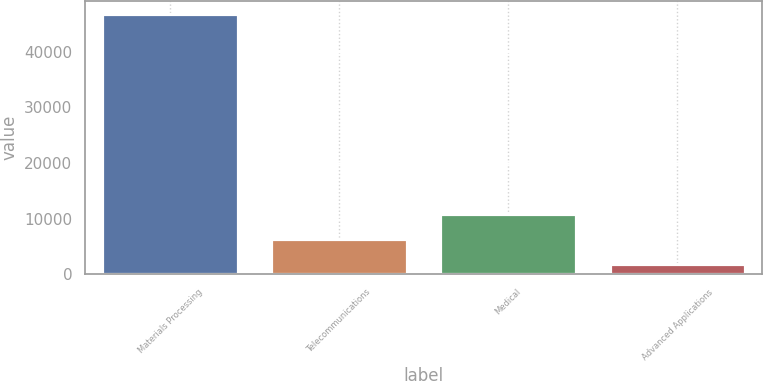Convert chart to OTSL. <chart><loc_0><loc_0><loc_500><loc_500><bar_chart><fcel>Materials Processing<fcel>Telecommunications<fcel>Medical<fcel>Advanced Applications<nl><fcel>46856<fcel>6383.9<fcel>10880.8<fcel>1887<nl></chart> 